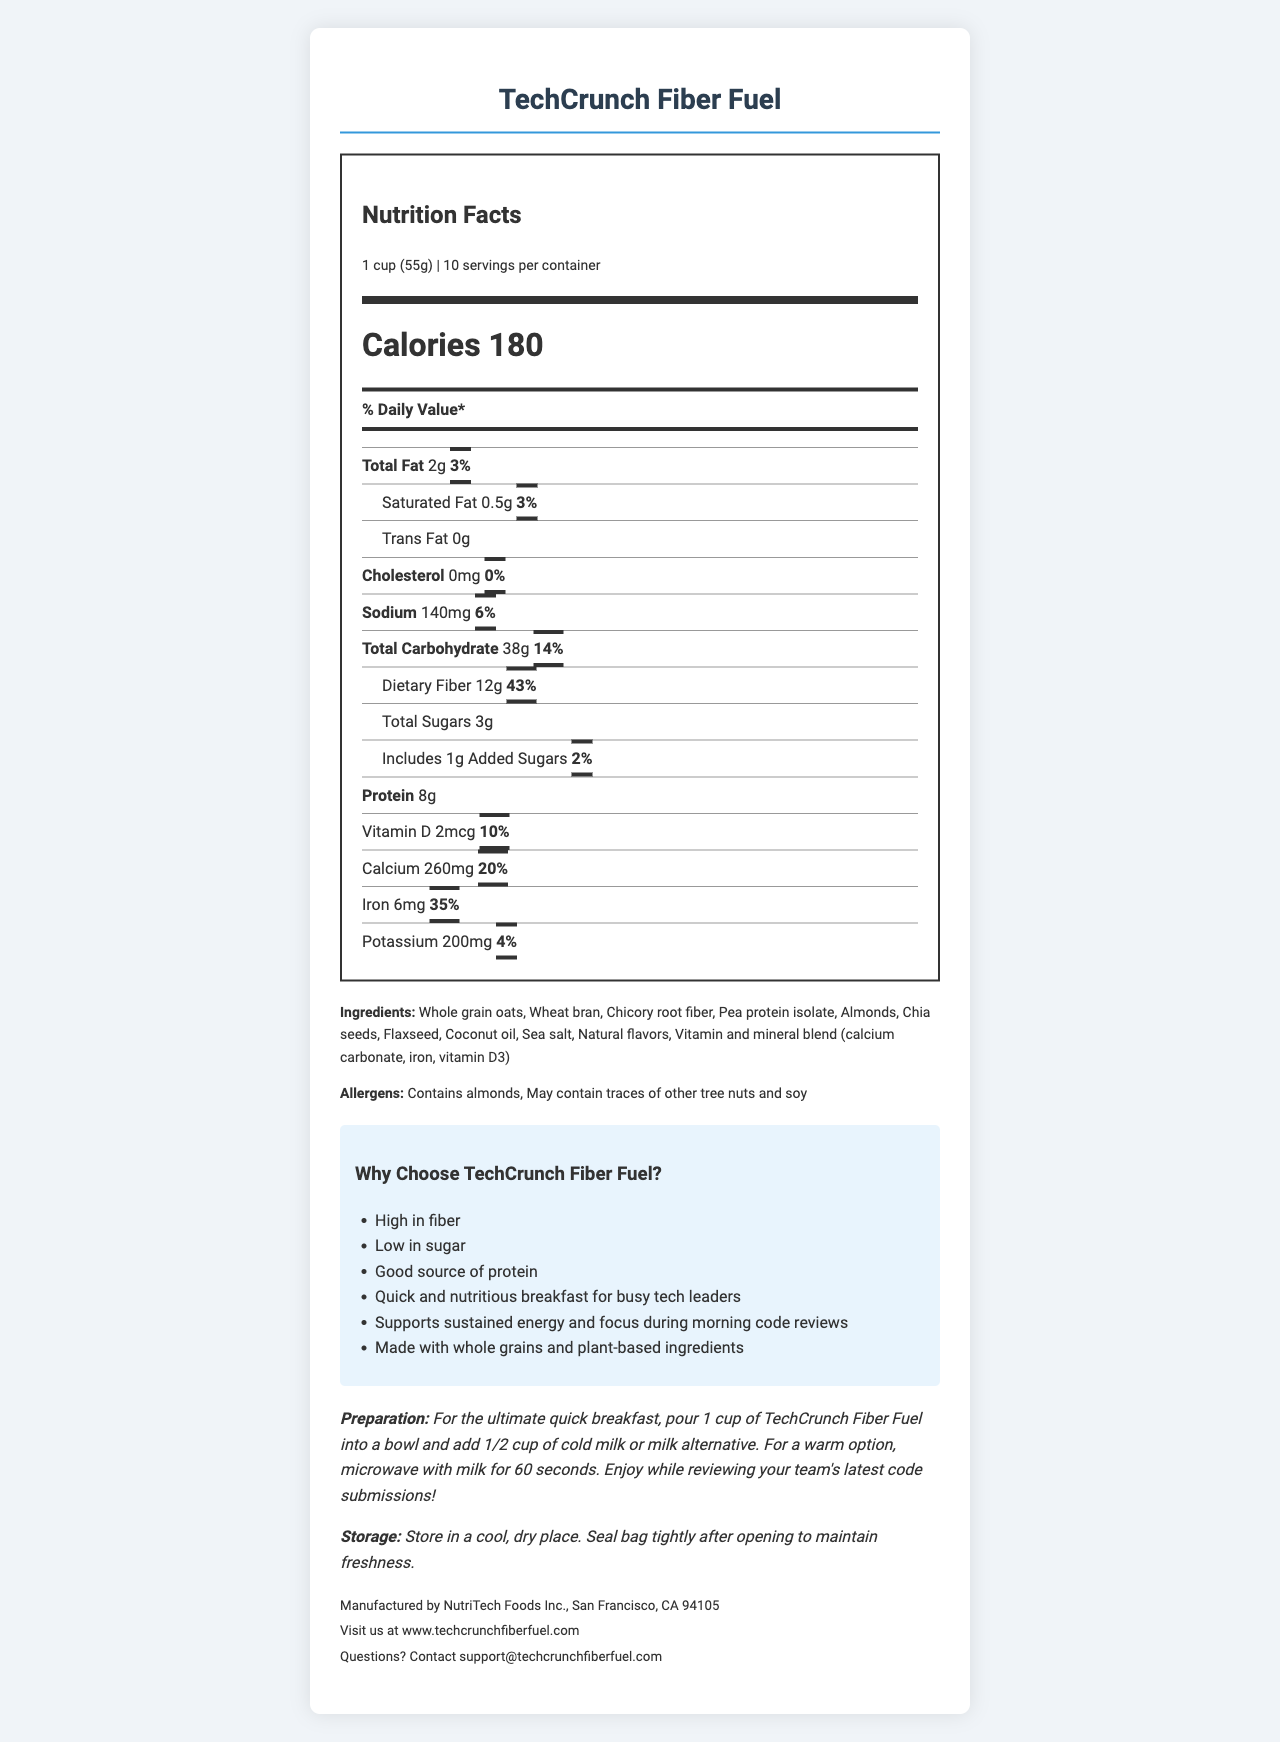what is the serving size? The serving size is explicitly mentioned at the top of the Nutrition Facts section.
Answer: 1 cup (55g) how many calories are in a single serving? The document mentions "Calories 180" in a prominent style.
Answer: 180 calories what percent of daily value is dietary fiber? The daily value percentage for dietary fiber is listed as 43%.
Answer: 43% which ingredient is the main source of protein in the cereal? Among the ingredients listed, pea protein isolate is a known source of protein.
Answer: Pea protein isolate what is the suggested preparation method for a warm breakfast option? The preparation instructions state to microwave with milk for 60 seconds for a warm option.
Answer: Microwave with milk for 60 seconds how many grams of total sugars are in a serving? The amount of total sugars is specified as 3g in the document.
Answer: 3g which claim is NOT made about this cereal? A. High in fiber B. Contains no artificial flavors C. Quick and nutritious breakfast D. Supports sustained energy The marketing claims list "High in fiber", "Quick and nutritious breakfast", and "Supports sustained energy", but there is no claim about containing no artificial flavors.
Answer: B how much calcium is provided per serving in terms of daily value percentage? A. 10% B. 15% C. 20% D. 25% The daily value percentage for calcium listed in the document is 20%.
Answer: C is this cereal gluten-free? The document does not specify whether the cereal is gluten-free, so we cannot determine this from the provided information.
Answer: Not enough information does the cereal contain any cholesterol? The cholesterol amount is listed as 0mg with a daily value of 0%, indicating no cholesterol.
Answer: No summarize the main nutritional benefits of TechCrunch Fiber Fuel. The document emphasizes the cereal's high fiber content, low sugar, good protein source, benefits for energy and focus, which are critical features highlighted in the marketing claims and nutritional information.
Answer: High in fiber, low in sugar, good source of protein, provides sustained energy, supports focus during morning activities what is the total carbohydrate content per serving? The document specifies the total carbohydrate content as 38g.
Answer: 38g who manufactures TechCrunch Fiber Fuel and where are they located? The manufacturer and location are explicitly stated at the end of the document.
Answer: NutriTech Foods Inc., San Francisco, CA 94105 how should the cereal be stored after opening? The storage instructions mention to store in a cool, dry place and to seal the bag tightly after opening.
Answer: Store in a cool, dry place. Seal bag tightly how does TechCrunch Fiber Fuel support busy tech leaders? The document and marketing claims outline that the cereal is designed for a quick, nutritious breakfast that supports sustained energy and focus, which are important for busy tech leaders.
Answer: By providing a quick, nutritious breakfast that sustains energy and focus 